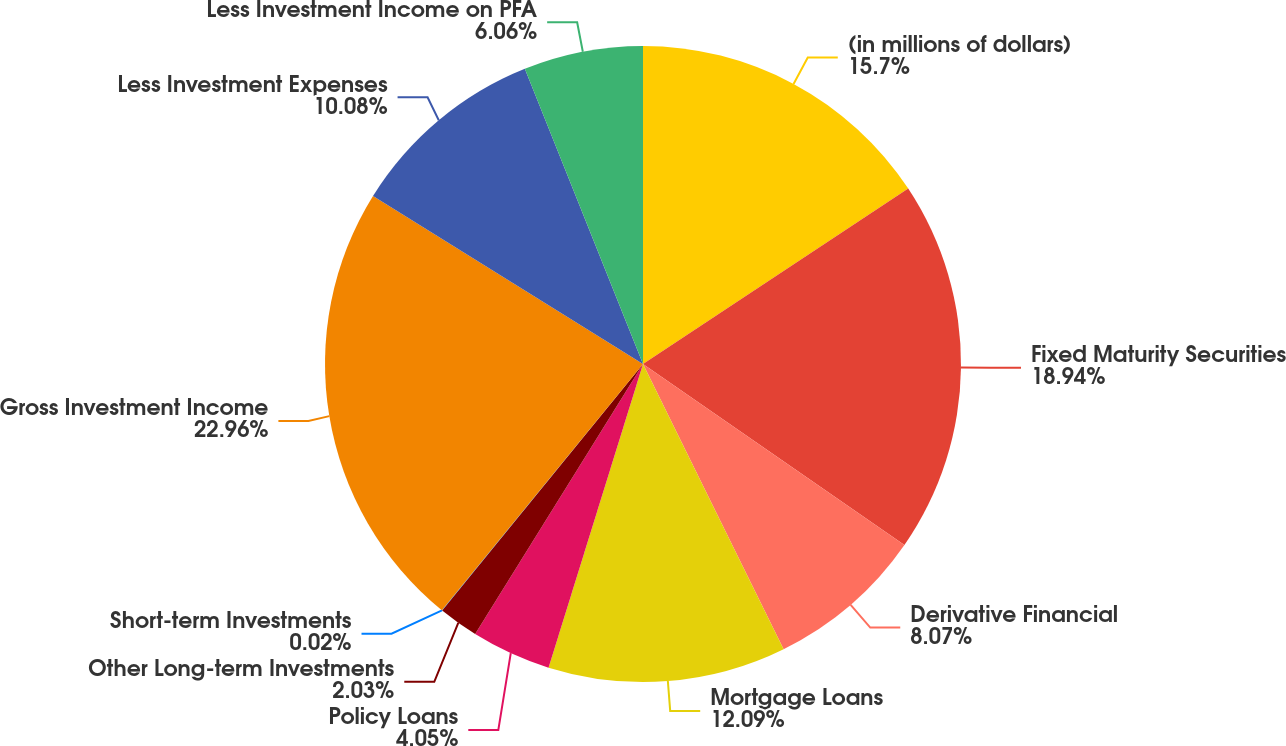Convert chart to OTSL. <chart><loc_0><loc_0><loc_500><loc_500><pie_chart><fcel>(in millions of dollars)<fcel>Fixed Maturity Securities<fcel>Derivative Financial<fcel>Mortgage Loans<fcel>Policy Loans<fcel>Other Long-term Investments<fcel>Short-term Investments<fcel>Gross Investment Income<fcel>Less Investment Expenses<fcel>Less Investment Income on PFA<nl><fcel>15.7%<fcel>18.94%<fcel>8.07%<fcel>12.09%<fcel>4.05%<fcel>2.03%<fcel>0.02%<fcel>22.96%<fcel>10.08%<fcel>6.06%<nl></chart> 